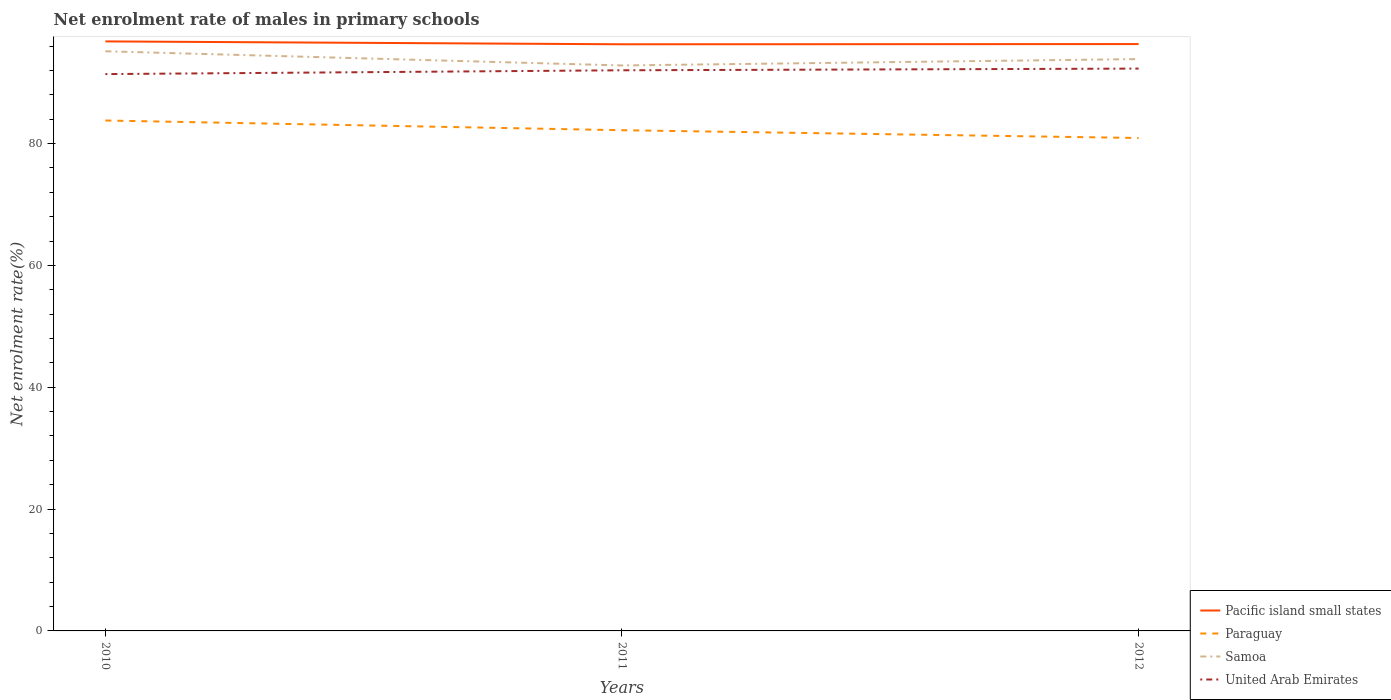Is the number of lines equal to the number of legend labels?
Ensure brevity in your answer.  Yes. Across all years, what is the maximum net enrolment rate of males in primary schools in Samoa?
Your answer should be compact. 92.82. What is the total net enrolment rate of males in primary schools in Paraguay in the graph?
Give a very brief answer. 2.87. What is the difference between the highest and the second highest net enrolment rate of males in primary schools in Pacific island small states?
Ensure brevity in your answer.  0.47. What is the difference between the highest and the lowest net enrolment rate of males in primary schools in Samoa?
Provide a short and direct response. 1. Is the net enrolment rate of males in primary schools in Samoa strictly greater than the net enrolment rate of males in primary schools in Pacific island small states over the years?
Keep it short and to the point. Yes. How many years are there in the graph?
Offer a terse response. 3. What is the difference between two consecutive major ticks on the Y-axis?
Your answer should be very brief. 20. How many legend labels are there?
Make the answer very short. 4. How are the legend labels stacked?
Your answer should be very brief. Vertical. What is the title of the graph?
Your answer should be very brief. Net enrolment rate of males in primary schools. What is the label or title of the X-axis?
Your answer should be compact. Years. What is the label or title of the Y-axis?
Keep it short and to the point. Net enrolment rate(%). What is the Net enrolment rate(%) in Pacific island small states in 2010?
Provide a short and direct response. 96.77. What is the Net enrolment rate(%) in Paraguay in 2010?
Offer a very short reply. 83.78. What is the Net enrolment rate(%) in Samoa in 2010?
Ensure brevity in your answer.  95.15. What is the Net enrolment rate(%) in United Arab Emirates in 2010?
Make the answer very short. 91.4. What is the Net enrolment rate(%) of Pacific island small states in 2011?
Give a very brief answer. 96.3. What is the Net enrolment rate(%) in Paraguay in 2011?
Keep it short and to the point. 82.19. What is the Net enrolment rate(%) in Samoa in 2011?
Your answer should be compact. 92.82. What is the Net enrolment rate(%) of United Arab Emirates in 2011?
Provide a succinct answer. 92.03. What is the Net enrolment rate(%) of Pacific island small states in 2012?
Keep it short and to the point. 96.33. What is the Net enrolment rate(%) in Paraguay in 2012?
Keep it short and to the point. 80.91. What is the Net enrolment rate(%) in Samoa in 2012?
Offer a terse response. 93.87. What is the Net enrolment rate(%) in United Arab Emirates in 2012?
Provide a succinct answer. 92.31. Across all years, what is the maximum Net enrolment rate(%) of Pacific island small states?
Provide a short and direct response. 96.77. Across all years, what is the maximum Net enrolment rate(%) of Paraguay?
Offer a terse response. 83.78. Across all years, what is the maximum Net enrolment rate(%) in Samoa?
Provide a succinct answer. 95.15. Across all years, what is the maximum Net enrolment rate(%) of United Arab Emirates?
Offer a terse response. 92.31. Across all years, what is the minimum Net enrolment rate(%) in Pacific island small states?
Ensure brevity in your answer.  96.3. Across all years, what is the minimum Net enrolment rate(%) of Paraguay?
Provide a succinct answer. 80.91. Across all years, what is the minimum Net enrolment rate(%) of Samoa?
Your answer should be very brief. 92.82. Across all years, what is the minimum Net enrolment rate(%) of United Arab Emirates?
Give a very brief answer. 91.4. What is the total Net enrolment rate(%) of Pacific island small states in the graph?
Keep it short and to the point. 289.4. What is the total Net enrolment rate(%) of Paraguay in the graph?
Keep it short and to the point. 246.89. What is the total Net enrolment rate(%) of Samoa in the graph?
Offer a very short reply. 281.84. What is the total Net enrolment rate(%) of United Arab Emirates in the graph?
Your answer should be compact. 275.74. What is the difference between the Net enrolment rate(%) in Pacific island small states in 2010 and that in 2011?
Provide a succinct answer. 0.47. What is the difference between the Net enrolment rate(%) in Paraguay in 2010 and that in 2011?
Offer a terse response. 1.6. What is the difference between the Net enrolment rate(%) of Samoa in 2010 and that in 2011?
Offer a very short reply. 2.33. What is the difference between the Net enrolment rate(%) in United Arab Emirates in 2010 and that in 2011?
Make the answer very short. -0.63. What is the difference between the Net enrolment rate(%) of Pacific island small states in 2010 and that in 2012?
Offer a very short reply. 0.44. What is the difference between the Net enrolment rate(%) of Paraguay in 2010 and that in 2012?
Make the answer very short. 2.87. What is the difference between the Net enrolment rate(%) of Samoa in 2010 and that in 2012?
Provide a succinct answer. 1.28. What is the difference between the Net enrolment rate(%) in United Arab Emirates in 2010 and that in 2012?
Give a very brief answer. -0.9. What is the difference between the Net enrolment rate(%) of Pacific island small states in 2011 and that in 2012?
Make the answer very short. -0.04. What is the difference between the Net enrolment rate(%) in Paraguay in 2011 and that in 2012?
Your answer should be compact. 1.27. What is the difference between the Net enrolment rate(%) of Samoa in 2011 and that in 2012?
Your answer should be very brief. -1.05. What is the difference between the Net enrolment rate(%) in United Arab Emirates in 2011 and that in 2012?
Your answer should be very brief. -0.28. What is the difference between the Net enrolment rate(%) of Pacific island small states in 2010 and the Net enrolment rate(%) of Paraguay in 2011?
Offer a very short reply. 14.58. What is the difference between the Net enrolment rate(%) of Pacific island small states in 2010 and the Net enrolment rate(%) of Samoa in 2011?
Your response must be concise. 3.95. What is the difference between the Net enrolment rate(%) of Pacific island small states in 2010 and the Net enrolment rate(%) of United Arab Emirates in 2011?
Keep it short and to the point. 4.74. What is the difference between the Net enrolment rate(%) of Paraguay in 2010 and the Net enrolment rate(%) of Samoa in 2011?
Ensure brevity in your answer.  -9.04. What is the difference between the Net enrolment rate(%) of Paraguay in 2010 and the Net enrolment rate(%) of United Arab Emirates in 2011?
Your response must be concise. -8.24. What is the difference between the Net enrolment rate(%) of Samoa in 2010 and the Net enrolment rate(%) of United Arab Emirates in 2011?
Your answer should be very brief. 3.12. What is the difference between the Net enrolment rate(%) in Pacific island small states in 2010 and the Net enrolment rate(%) in Paraguay in 2012?
Provide a short and direct response. 15.85. What is the difference between the Net enrolment rate(%) of Pacific island small states in 2010 and the Net enrolment rate(%) of Samoa in 2012?
Your answer should be very brief. 2.9. What is the difference between the Net enrolment rate(%) of Pacific island small states in 2010 and the Net enrolment rate(%) of United Arab Emirates in 2012?
Provide a succinct answer. 4.46. What is the difference between the Net enrolment rate(%) in Paraguay in 2010 and the Net enrolment rate(%) in Samoa in 2012?
Ensure brevity in your answer.  -10.08. What is the difference between the Net enrolment rate(%) of Paraguay in 2010 and the Net enrolment rate(%) of United Arab Emirates in 2012?
Your response must be concise. -8.52. What is the difference between the Net enrolment rate(%) of Samoa in 2010 and the Net enrolment rate(%) of United Arab Emirates in 2012?
Keep it short and to the point. 2.84. What is the difference between the Net enrolment rate(%) in Pacific island small states in 2011 and the Net enrolment rate(%) in Paraguay in 2012?
Ensure brevity in your answer.  15.38. What is the difference between the Net enrolment rate(%) of Pacific island small states in 2011 and the Net enrolment rate(%) of Samoa in 2012?
Offer a terse response. 2.43. What is the difference between the Net enrolment rate(%) in Pacific island small states in 2011 and the Net enrolment rate(%) in United Arab Emirates in 2012?
Your answer should be very brief. 3.99. What is the difference between the Net enrolment rate(%) in Paraguay in 2011 and the Net enrolment rate(%) in Samoa in 2012?
Your answer should be very brief. -11.68. What is the difference between the Net enrolment rate(%) of Paraguay in 2011 and the Net enrolment rate(%) of United Arab Emirates in 2012?
Keep it short and to the point. -10.12. What is the difference between the Net enrolment rate(%) in Samoa in 2011 and the Net enrolment rate(%) in United Arab Emirates in 2012?
Provide a succinct answer. 0.51. What is the average Net enrolment rate(%) in Pacific island small states per year?
Give a very brief answer. 96.47. What is the average Net enrolment rate(%) in Paraguay per year?
Your answer should be compact. 82.3. What is the average Net enrolment rate(%) in Samoa per year?
Keep it short and to the point. 93.95. What is the average Net enrolment rate(%) in United Arab Emirates per year?
Your response must be concise. 91.91. In the year 2010, what is the difference between the Net enrolment rate(%) in Pacific island small states and Net enrolment rate(%) in Paraguay?
Your answer should be very brief. 12.98. In the year 2010, what is the difference between the Net enrolment rate(%) in Pacific island small states and Net enrolment rate(%) in Samoa?
Offer a terse response. 1.62. In the year 2010, what is the difference between the Net enrolment rate(%) of Pacific island small states and Net enrolment rate(%) of United Arab Emirates?
Your answer should be compact. 5.37. In the year 2010, what is the difference between the Net enrolment rate(%) in Paraguay and Net enrolment rate(%) in Samoa?
Offer a very short reply. -11.37. In the year 2010, what is the difference between the Net enrolment rate(%) of Paraguay and Net enrolment rate(%) of United Arab Emirates?
Your answer should be very brief. -7.62. In the year 2010, what is the difference between the Net enrolment rate(%) in Samoa and Net enrolment rate(%) in United Arab Emirates?
Give a very brief answer. 3.75. In the year 2011, what is the difference between the Net enrolment rate(%) of Pacific island small states and Net enrolment rate(%) of Paraguay?
Ensure brevity in your answer.  14.11. In the year 2011, what is the difference between the Net enrolment rate(%) in Pacific island small states and Net enrolment rate(%) in Samoa?
Provide a short and direct response. 3.48. In the year 2011, what is the difference between the Net enrolment rate(%) in Pacific island small states and Net enrolment rate(%) in United Arab Emirates?
Keep it short and to the point. 4.27. In the year 2011, what is the difference between the Net enrolment rate(%) of Paraguay and Net enrolment rate(%) of Samoa?
Your answer should be very brief. -10.63. In the year 2011, what is the difference between the Net enrolment rate(%) in Paraguay and Net enrolment rate(%) in United Arab Emirates?
Give a very brief answer. -9.84. In the year 2011, what is the difference between the Net enrolment rate(%) of Samoa and Net enrolment rate(%) of United Arab Emirates?
Ensure brevity in your answer.  0.79. In the year 2012, what is the difference between the Net enrolment rate(%) of Pacific island small states and Net enrolment rate(%) of Paraguay?
Make the answer very short. 15.42. In the year 2012, what is the difference between the Net enrolment rate(%) of Pacific island small states and Net enrolment rate(%) of Samoa?
Offer a very short reply. 2.46. In the year 2012, what is the difference between the Net enrolment rate(%) of Pacific island small states and Net enrolment rate(%) of United Arab Emirates?
Your answer should be very brief. 4.03. In the year 2012, what is the difference between the Net enrolment rate(%) in Paraguay and Net enrolment rate(%) in Samoa?
Offer a terse response. -12.95. In the year 2012, what is the difference between the Net enrolment rate(%) in Paraguay and Net enrolment rate(%) in United Arab Emirates?
Offer a very short reply. -11.39. In the year 2012, what is the difference between the Net enrolment rate(%) of Samoa and Net enrolment rate(%) of United Arab Emirates?
Make the answer very short. 1.56. What is the ratio of the Net enrolment rate(%) in Pacific island small states in 2010 to that in 2011?
Your response must be concise. 1. What is the ratio of the Net enrolment rate(%) in Paraguay in 2010 to that in 2011?
Your answer should be compact. 1.02. What is the ratio of the Net enrolment rate(%) in Samoa in 2010 to that in 2011?
Provide a short and direct response. 1.03. What is the ratio of the Net enrolment rate(%) of Pacific island small states in 2010 to that in 2012?
Offer a terse response. 1. What is the ratio of the Net enrolment rate(%) of Paraguay in 2010 to that in 2012?
Provide a short and direct response. 1.04. What is the ratio of the Net enrolment rate(%) of Samoa in 2010 to that in 2012?
Your answer should be compact. 1.01. What is the ratio of the Net enrolment rate(%) of United Arab Emirates in 2010 to that in 2012?
Ensure brevity in your answer.  0.99. What is the ratio of the Net enrolment rate(%) in Pacific island small states in 2011 to that in 2012?
Offer a very short reply. 1. What is the ratio of the Net enrolment rate(%) of Paraguay in 2011 to that in 2012?
Give a very brief answer. 1.02. What is the ratio of the Net enrolment rate(%) of Samoa in 2011 to that in 2012?
Keep it short and to the point. 0.99. What is the ratio of the Net enrolment rate(%) of United Arab Emirates in 2011 to that in 2012?
Provide a short and direct response. 1. What is the difference between the highest and the second highest Net enrolment rate(%) of Pacific island small states?
Offer a terse response. 0.44. What is the difference between the highest and the second highest Net enrolment rate(%) of Paraguay?
Provide a short and direct response. 1.6. What is the difference between the highest and the second highest Net enrolment rate(%) of Samoa?
Provide a succinct answer. 1.28. What is the difference between the highest and the second highest Net enrolment rate(%) in United Arab Emirates?
Keep it short and to the point. 0.28. What is the difference between the highest and the lowest Net enrolment rate(%) of Pacific island small states?
Provide a succinct answer. 0.47. What is the difference between the highest and the lowest Net enrolment rate(%) of Paraguay?
Make the answer very short. 2.87. What is the difference between the highest and the lowest Net enrolment rate(%) in Samoa?
Ensure brevity in your answer.  2.33. What is the difference between the highest and the lowest Net enrolment rate(%) in United Arab Emirates?
Offer a terse response. 0.9. 